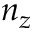Convert formula to latex. <formula><loc_0><loc_0><loc_500><loc_500>n _ { z }</formula> 